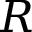Convert formula to latex. <formula><loc_0><loc_0><loc_500><loc_500>R</formula> 